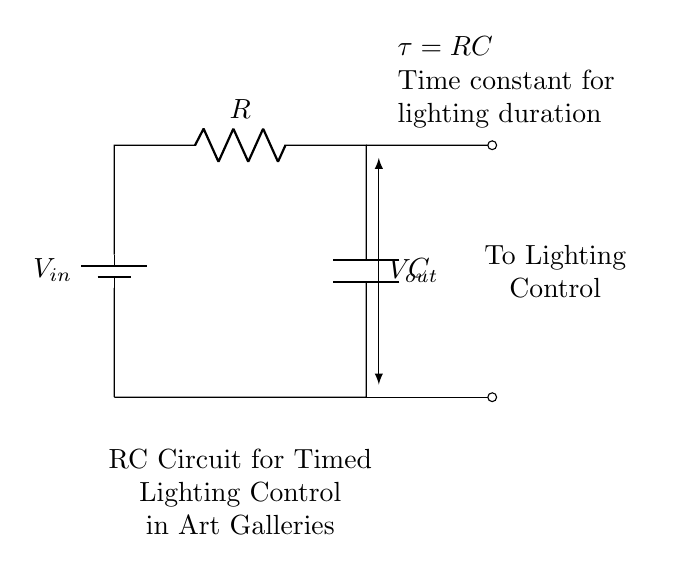What is the input voltage of this circuit? The input voltage is indicated at the battery symbol labeled V_in at the top of the circuit. It represents the voltage supplied to the circuit.
Answer: V_in What is the function of the capacitor? The capacitor in an RC circuit is charged over time, affecting the time it takes for the lighting control to turn on or off, thus serving a timing function in this circuit.
Answer: Timing What does the time constant represent? The time constant, represented by tau (τ), is calculated as the product of resistance (R) and capacitance (C) in the circuit and indicates how long it takes for the output voltage to reach approximately 63% of the input voltage during charging.
Answer: RC What connection does the output voltage represent? The output voltage is taken across the capacitor, indicating the voltage level that controls the lighting based on the charged state of the capacitor.
Answer: Capacitor If the resistance is doubled, how is the time constant affected? If the resistance is doubled, the time constant (τ = RC) also doubles because it is directly proportional to resistance; hence, the lighting duration increases.
Answer: Doubles What type of circuit is this? This circuit is classified as an RC timing circuit, as it incorporates both a resistor and a capacitor to manage time-based voltage control for lighting purposes.
Answer: RC circuit What effect does increasing the capacitance have on the timing? Increasing the capacitance will also increase the time constant (τ), leading to a longer time duration for the output voltage to rise and control the lighting.
Answer: Increases duration 